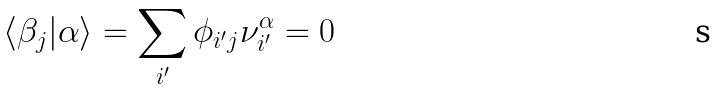<formula> <loc_0><loc_0><loc_500><loc_500>\langle \beta _ { j } | \alpha \rangle = \sum _ { i ^ { \prime } } \phi _ { i ^ { \prime } j } \nu ^ { \alpha } _ { i ^ { \prime } } = 0</formula> 